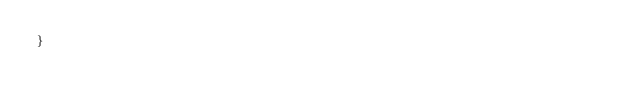<code> <loc_0><loc_0><loc_500><loc_500><_Kotlin_>}

</code> 